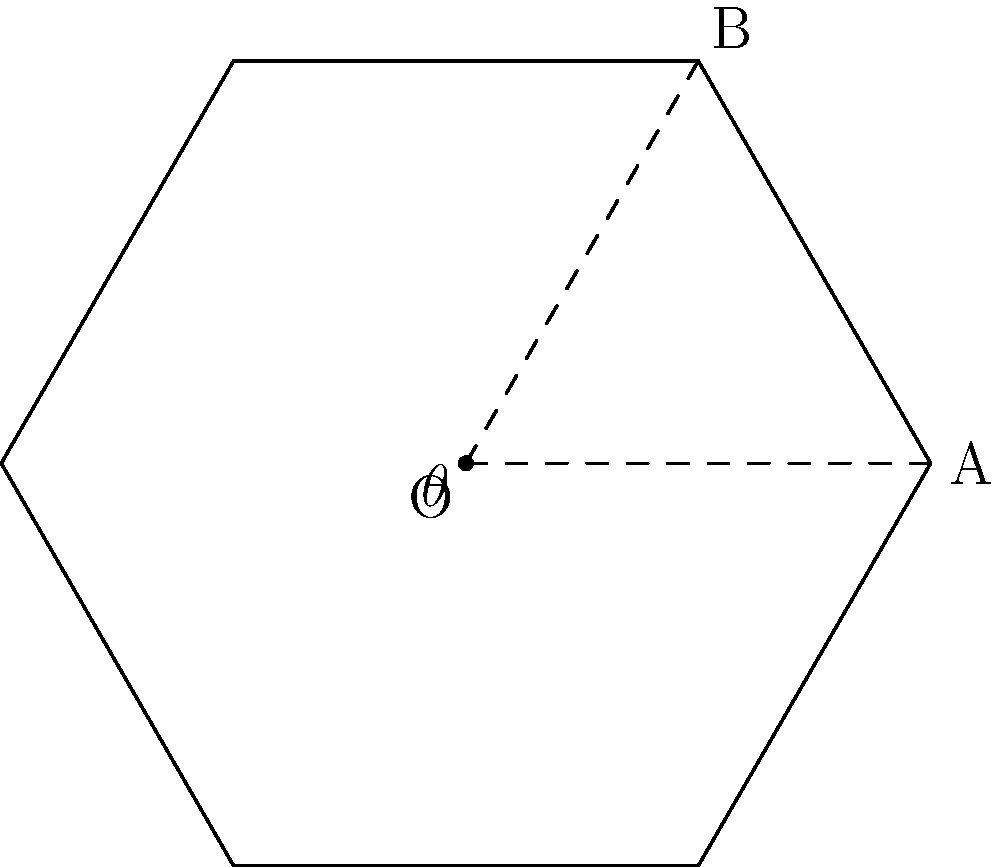In the regular hexagon shown above, angle $\theta$ represents the central angle between two adjacent vertices. If we increase the number of sides in this regular polygon to 8, how would the measure of angle $\theta$ change? Express your answer in degrees and round to the nearest whole number. Let's approach this step-by-step:

1) For any regular polygon with $n$ sides, the central angle $\theta$ is given by the formula:

   $$\theta = \frac{360^\circ}{n}$$

2) For the hexagon in the diagram (6 sides):
   $$\theta_{hexagon} = \frac{360^\circ}{6} = 60^\circ$$

3) If we increase the number of sides to 8 (octagon):
   $$\theta_{octagon} = \frac{360^\circ}{8} = 45^\circ$$

4) To find the change, we subtract:
   $$\text{Change} = \theta_{hexagon} - \theta_{octagon} = 60^\circ - 45^\circ = 15^\circ$$

Therefore, the central angle would decrease by 15°.

This problem relates to our shared experience as new graduates, as we often face situations where we need to adapt to changes and understand how modifications affect the overall structure, whether in geometry or in our daily lives.
Answer: 15° 